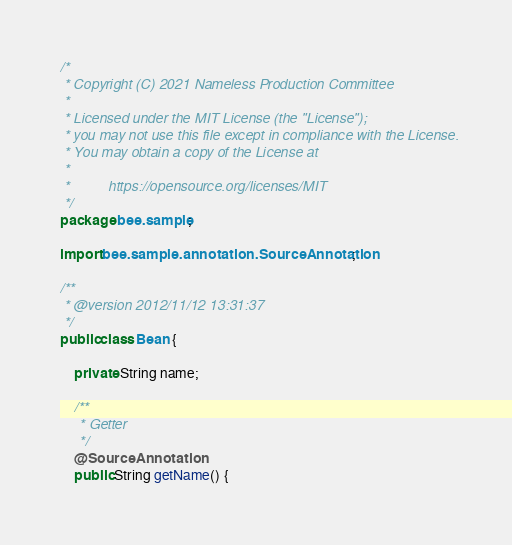Convert code to text. <code><loc_0><loc_0><loc_500><loc_500><_Java_>/*
 * Copyright (C) 2021 Nameless Production Committee
 *
 * Licensed under the MIT License (the "License");
 * you may not use this file except in compliance with the License.
 * You may obtain a copy of the License at
 *
 *          https://opensource.org/licenses/MIT
 */
package bee.sample;

import bee.sample.annotation.SourceAnnotation;

/**
 * @version 2012/11/12 13:31:37
 */
public class Bean {

    private String name;

    /**
     * Getter
     */
    @SourceAnnotation
    public String getName() {</code> 